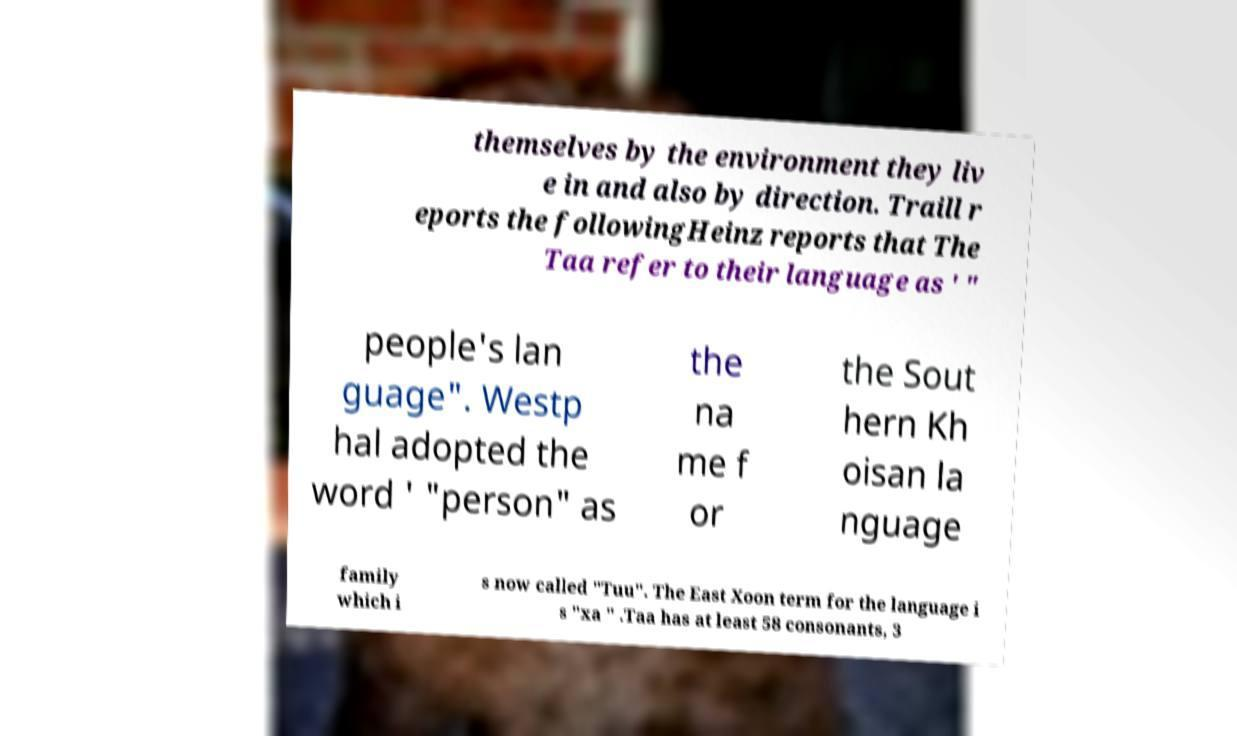Please read and relay the text visible in this image. What does it say? themselves by the environment they liv e in and also by direction. Traill r eports the followingHeinz reports that The Taa refer to their language as ' " people's lan guage". Westp hal adopted the word ' "person" as the na me f or the Sout hern Kh oisan la nguage family which i s now called "Tuu". The East Xoon term for the language i s "xa " .Taa has at least 58 consonants, 3 